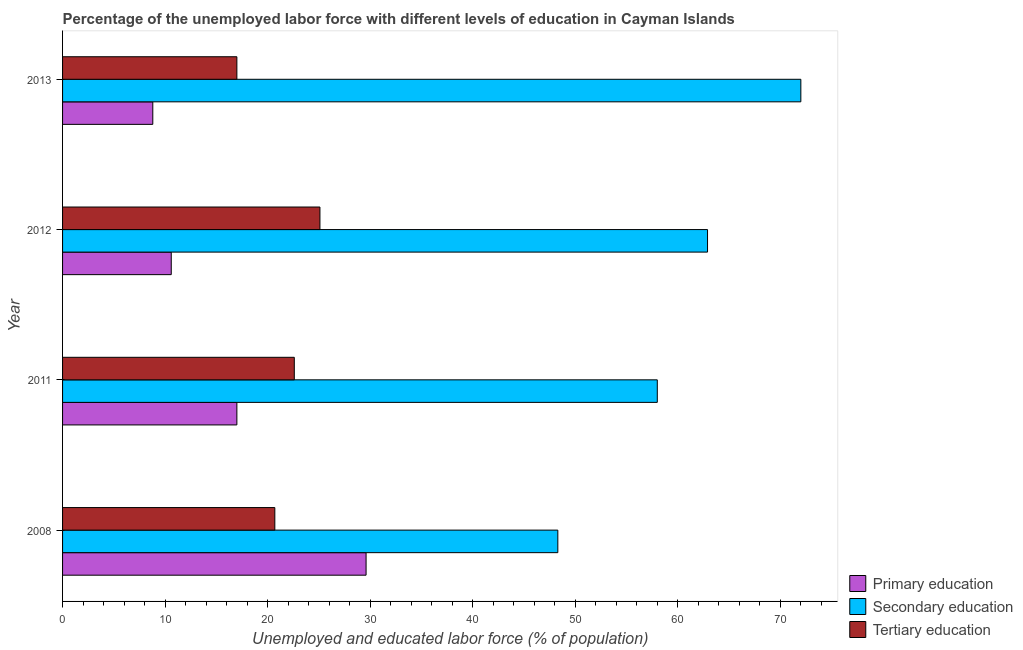How many different coloured bars are there?
Provide a short and direct response. 3. How many groups of bars are there?
Your answer should be very brief. 4. Are the number of bars per tick equal to the number of legend labels?
Your response must be concise. Yes. How many bars are there on the 2nd tick from the top?
Give a very brief answer. 3. How many bars are there on the 4th tick from the bottom?
Your answer should be compact. 3. What is the percentage of labor force who received secondary education in 2013?
Your response must be concise. 72. Across all years, what is the maximum percentage of labor force who received secondary education?
Keep it short and to the point. 72. Across all years, what is the minimum percentage of labor force who received primary education?
Give a very brief answer. 8.8. In which year was the percentage of labor force who received tertiary education minimum?
Keep it short and to the point. 2013. What is the total percentage of labor force who received secondary education in the graph?
Your response must be concise. 241.2. What is the difference between the percentage of labor force who received primary education in 2011 and the percentage of labor force who received tertiary education in 2008?
Offer a very short reply. -3.7. What is the average percentage of labor force who received tertiary education per year?
Provide a short and direct response. 21.35. In the year 2012, what is the difference between the percentage of labor force who received tertiary education and percentage of labor force who received secondary education?
Make the answer very short. -37.8. In how many years, is the percentage of labor force who received tertiary education greater than 28 %?
Offer a very short reply. 0. What is the ratio of the percentage of labor force who received primary education in 2012 to that in 2013?
Keep it short and to the point. 1.21. What is the difference between the highest and the lowest percentage of labor force who received primary education?
Give a very brief answer. 20.8. In how many years, is the percentage of labor force who received primary education greater than the average percentage of labor force who received primary education taken over all years?
Your answer should be compact. 2. What does the 1st bar from the top in 2011 represents?
Ensure brevity in your answer.  Tertiary education. What does the 1st bar from the bottom in 2012 represents?
Keep it short and to the point. Primary education. Is it the case that in every year, the sum of the percentage of labor force who received primary education and percentage of labor force who received secondary education is greater than the percentage of labor force who received tertiary education?
Offer a very short reply. Yes. How many bars are there?
Provide a short and direct response. 12. Are all the bars in the graph horizontal?
Make the answer very short. Yes. How many years are there in the graph?
Keep it short and to the point. 4. What is the difference between two consecutive major ticks on the X-axis?
Offer a very short reply. 10. Where does the legend appear in the graph?
Provide a short and direct response. Bottom right. What is the title of the graph?
Keep it short and to the point. Percentage of the unemployed labor force with different levels of education in Cayman Islands. What is the label or title of the X-axis?
Ensure brevity in your answer.  Unemployed and educated labor force (% of population). What is the Unemployed and educated labor force (% of population) in Primary education in 2008?
Provide a succinct answer. 29.6. What is the Unemployed and educated labor force (% of population) in Secondary education in 2008?
Offer a terse response. 48.3. What is the Unemployed and educated labor force (% of population) of Tertiary education in 2008?
Make the answer very short. 20.7. What is the Unemployed and educated labor force (% of population) of Primary education in 2011?
Provide a succinct answer. 17. What is the Unemployed and educated labor force (% of population) of Secondary education in 2011?
Give a very brief answer. 58. What is the Unemployed and educated labor force (% of population) in Tertiary education in 2011?
Your answer should be very brief. 22.6. What is the Unemployed and educated labor force (% of population) in Primary education in 2012?
Offer a very short reply. 10.6. What is the Unemployed and educated labor force (% of population) of Secondary education in 2012?
Keep it short and to the point. 62.9. What is the Unemployed and educated labor force (% of population) in Tertiary education in 2012?
Give a very brief answer. 25.1. What is the Unemployed and educated labor force (% of population) in Primary education in 2013?
Your answer should be compact. 8.8. What is the Unemployed and educated labor force (% of population) in Secondary education in 2013?
Your response must be concise. 72. What is the Unemployed and educated labor force (% of population) in Tertiary education in 2013?
Provide a short and direct response. 17. Across all years, what is the maximum Unemployed and educated labor force (% of population) of Primary education?
Your response must be concise. 29.6. Across all years, what is the maximum Unemployed and educated labor force (% of population) of Secondary education?
Your response must be concise. 72. Across all years, what is the maximum Unemployed and educated labor force (% of population) in Tertiary education?
Offer a very short reply. 25.1. Across all years, what is the minimum Unemployed and educated labor force (% of population) in Primary education?
Ensure brevity in your answer.  8.8. Across all years, what is the minimum Unemployed and educated labor force (% of population) of Secondary education?
Offer a very short reply. 48.3. What is the total Unemployed and educated labor force (% of population) in Primary education in the graph?
Make the answer very short. 66. What is the total Unemployed and educated labor force (% of population) in Secondary education in the graph?
Keep it short and to the point. 241.2. What is the total Unemployed and educated labor force (% of population) of Tertiary education in the graph?
Keep it short and to the point. 85.4. What is the difference between the Unemployed and educated labor force (% of population) of Primary education in 2008 and that in 2011?
Provide a short and direct response. 12.6. What is the difference between the Unemployed and educated labor force (% of population) of Secondary education in 2008 and that in 2011?
Offer a terse response. -9.7. What is the difference between the Unemployed and educated labor force (% of population) of Tertiary education in 2008 and that in 2011?
Offer a very short reply. -1.9. What is the difference between the Unemployed and educated labor force (% of population) in Primary education in 2008 and that in 2012?
Provide a succinct answer. 19. What is the difference between the Unemployed and educated labor force (% of population) in Secondary education in 2008 and that in 2012?
Your answer should be compact. -14.6. What is the difference between the Unemployed and educated labor force (% of population) of Tertiary education in 2008 and that in 2012?
Your response must be concise. -4.4. What is the difference between the Unemployed and educated labor force (% of population) of Primary education in 2008 and that in 2013?
Keep it short and to the point. 20.8. What is the difference between the Unemployed and educated labor force (% of population) in Secondary education in 2008 and that in 2013?
Offer a terse response. -23.7. What is the difference between the Unemployed and educated labor force (% of population) of Primary education in 2011 and that in 2012?
Make the answer very short. 6.4. What is the difference between the Unemployed and educated labor force (% of population) of Secondary education in 2011 and that in 2012?
Your response must be concise. -4.9. What is the difference between the Unemployed and educated labor force (% of population) in Secondary education in 2011 and that in 2013?
Your response must be concise. -14. What is the difference between the Unemployed and educated labor force (% of population) in Tertiary education in 2011 and that in 2013?
Make the answer very short. 5.6. What is the difference between the Unemployed and educated labor force (% of population) in Secondary education in 2012 and that in 2013?
Provide a short and direct response. -9.1. What is the difference between the Unemployed and educated labor force (% of population) in Tertiary education in 2012 and that in 2013?
Keep it short and to the point. 8.1. What is the difference between the Unemployed and educated labor force (% of population) of Primary education in 2008 and the Unemployed and educated labor force (% of population) of Secondary education in 2011?
Your answer should be compact. -28.4. What is the difference between the Unemployed and educated labor force (% of population) of Primary education in 2008 and the Unemployed and educated labor force (% of population) of Tertiary education in 2011?
Your answer should be compact. 7. What is the difference between the Unemployed and educated labor force (% of population) in Secondary education in 2008 and the Unemployed and educated labor force (% of population) in Tertiary education in 2011?
Your response must be concise. 25.7. What is the difference between the Unemployed and educated labor force (% of population) in Primary education in 2008 and the Unemployed and educated labor force (% of population) in Secondary education in 2012?
Offer a terse response. -33.3. What is the difference between the Unemployed and educated labor force (% of population) of Primary education in 2008 and the Unemployed and educated labor force (% of population) of Tertiary education in 2012?
Offer a terse response. 4.5. What is the difference between the Unemployed and educated labor force (% of population) of Secondary education in 2008 and the Unemployed and educated labor force (% of population) of Tertiary education in 2012?
Your response must be concise. 23.2. What is the difference between the Unemployed and educated labor force (% of population) of Primary education in 2008 and the Unemployed and educated labor force (% of population) of Secondary education in 2013?
Offer a very short reply. -42.4. What is the difference between the Unemployed and educated labor force (% of population) of Secondary education in 2008 and the Unemployed and educated labor force (% of population) of Tertiary education in 2013?
Your answer should be compact. 31.3. What is the difference between the Unemployed and educated labor force (% of population) of Primary education in 2011 and the Unemployed and educated labor force (% of population) of Secondary education in 2012?
Your answer should be very brief. -45.9. What is the difference between the Unemployed and educated labor force (% of population) of Secondary education in 2011 and the Unemployed and educated labor force (% of population) of Tertiary education in 2012?
Offer a very short reply. 32.9. What is the difference between the Unemployed and educated labor force (% of population) of Primary education in 2011 and the Unemployed and educated labor force (% of population) of Secondary education in 2013?
Ensure brevity in your answer.  -55. What is the difference between the Unemployed and educated labor force (% of population) in Primary education in 2011 and the Unemployed and educated labor force (% of population) in Tertiary education in 2013?
Give a very brief answer. 0. What is the difference between the Unemployed and educated labor force (% of population) in Secondary education in 2011 and the Unemployed and educated labor force (% of population) in Tertiary education in 2013?
Your answer should be very brief. 41. What is the difference between the Unemployed and educated labor force (% of population) of Primary education in 2012 and the Unemployed and educated labor force (% of population) of Secondary education in 2013?
Offer a terse response. -61.4. What is the difference between the Unemployed and educated labor force (% of population) in Secondary education in 2012 and the Unemployed and educated labor force (% of population) in Tertiary education in 2013?
Give a very brief answer. 45.9. What is the average Unemployed and educated labor force (% of population) in Secondary education per year?
Give a very brief answer. 60.3. What is the average Unemployed and educated labor force (% of population) in Tertiary education per year?
Offer a very short reply. 21.35. In the year 2008, what is the difference between the Unemployed and educated labor force (% of population) of Primary education and Unemployed and educated labor force (% of population) of Secondary education?
Offer a very short reply. -18.7. In the year 2008, what is the difference between the Unemployed and educated labor force (% of population) in Secondary education and Unemployed and educated labor force (% of population) in Tertiary education?
Offer a very short reply. 27.6. In the year 2011, what is the difference between the Unemployed and educated labor force (% of population) in Primary education and Unemployed and educated labor force (% of population) in Secondary education?
Offer a very short reply. -41. In the year 2011, what is the difference between the Unemployed and educated labor force (% of population) in Primary education and Unemployed and educated labor force (% of population) in Tertiary education?
Your answer should be very brief. -5.6. In the year 2011, what is the difference between the Unemployed and educated labor force (% of population) in Secondary education and Unemployed and educated labor force (% of population) in Tertiary education?
Give a very brief answer. 35.4. In the year 2012, what is the difference between the Unemployed and educated labor force (% of population) in Primary education and Unemployed and educated labor force (% of population) in Secondary education?
Ensure brevity in your answer.  -52.3. In the year 2012, what is the difference between the Unemployed and educated labor force (% of population) of Primary education and Unemployed and educated labor force (% of population) of Tertiary education?
Your answer should be very brief. -14.5. In the year 2012, what is the difference between the Unemployed and educated labor force (% of population) of Secondary education and Unemployed and educated labor force (% of population) of Tertiary education?
Provide a succinct answer. 37.8. In the year 2013, what is the difference between the Unemployed and educated labor force (% of population) in Primary education and Unemployed and educated labor force (% of population) in Secondary education?
Give a very brief answer. -63.2. What is the ratio of the Unemployed and educated labor force (% of population) in Primary education in 2008 to that in 2011?
Offer a very short reply. 1.74. What is the ratio of the Unemployed and educated labor force (% of population) in Secondary education in 2008 to that in 2011?
Provide a succinct answer. 0.83. What is the ratio of the Unemployed and educated labor force (% of population) of Tertiary education in 2008 to that in 2011?
Offer a very short reply. 0.92. What is the ratio of the Unemployed and educated labor force (% of population) in Primary education in 2008 to that in 2012?
Provide a succinct answer. 2.79. What is the ratio of the Unemployed and educated labor force (% of population) in Secondary education in 2008 to that in 2012?
Your answer should be compact. 0.77. What is the ratio of the Unemployed and educated labor force (% of population) in Tertiary education in 2008 to that in 2012?
Your answer should be very brief. 0.82. What is the ratio of the Unemployed and educated labor force (% of population) in Primary education in 2008 to that in 2013?
Ensure brevity in your answer.  3.36. What is the ratio of the Unemployed and educated labor force (% of population) of Secondary education in 2008 to that in 2013?
Your answer should be very brief. 0.67. What is the ratio of the Unemployed and educated labor force (% of population) of Tertiary education in 2008 to that in 2013?
Your response must be concise. 1.22. What is the ratio of the Unemployed and educated labor force (% of population) in Primary education in 2011 to that in 2012?
Keep it short and to the point. 1.6. What is the ratio of the Unemployed and educated labor force (% of population) in Secondary education in 2011 to that in 2012?
Your answer should be very brief. 0.92. What is the ratio of the Unemployed and educated labor force (% of population) in Tertiary education in 2011 to that in 2012?
Keep it short and to the point. 0.9. What is the ratio of the Unemployed and educated labor force (% of population) of Primary education in 2011 to that in 2013?
Your answer should be very brief. 1.93. What is the ratio of the Unemployed and educated labor force (% of population) of Secondary education in 2011 to that in 2013?
Your answer should be very brief. 0.81. What is the ratio of the Unemployed and educated labor force (% of population) in Tertiary education in 2011 to that in 2013?
Ensure brevity in your answer.  1.33. What is the ratio of the Unemployed and educated labor force (% of population) in Primary education in 2012 to that in 2013?
Give a very brief answer. 1.2. What is the ratio of the Unemployed and educated labor force (% of population) in Secondary education in 2012 to that in 2013?
Your answer should be very brief. 0.87. What is the ratio of the Unemployed and educated labor force (% of population) of Tertiary education in 2012 to that in 2013?
Provide a succinct answer. 1.48. What is the difference between the highest and the second highest Unemployed and educated labor force (% of population) of Tertiary education?
Provide a succinct answer. 2.5. What is the difference between the highest and the lowest Unemployed and educated labor force (% of population) in Primary education?
Your answer should be compact. 20.8. What is the difference between the highest and the lowest Unemployed and educated labor force (% of population) of Secondary education?
Your answer should be compact. 23.7. 